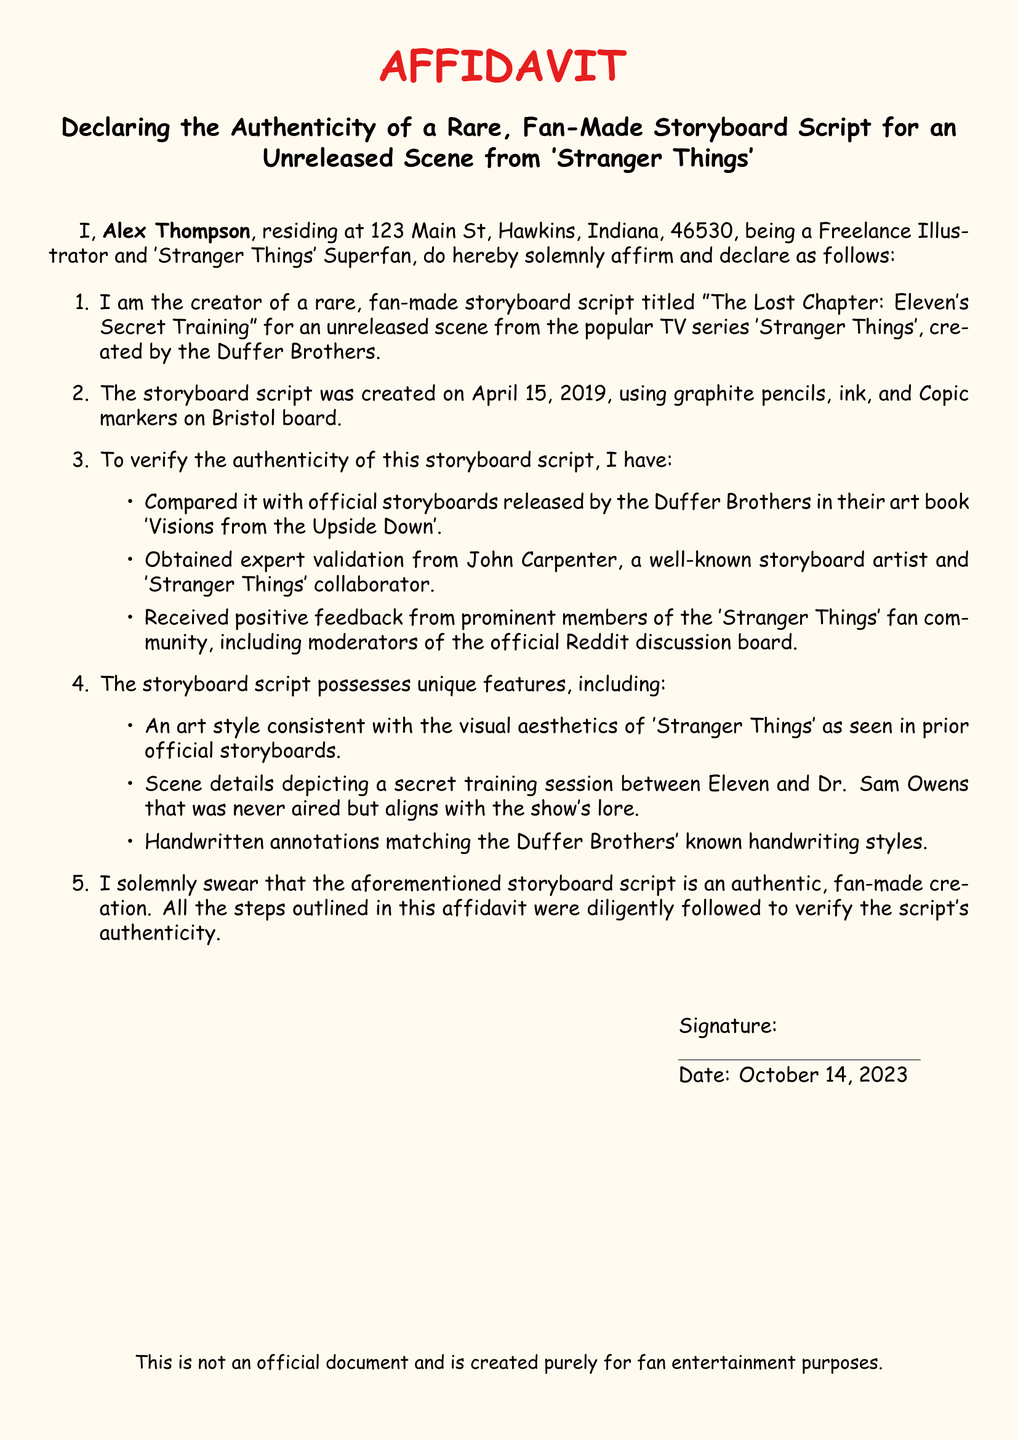What is the creator's name? The creator's name is stated in the affidavit as Alex Thompson.
Answer: Alex Thompson What is the title of the storyboard script? The title of the storyboard script is mentioned in the affidavit as "The Lost Chapter: Eleven's Secret Training".
Answer: The Lost Chapter: Eleven's Secret Training On what date was the storyboard script created? The date of creation is explicitly provided in the document as April 15, 2019.
Answer: April 15, 2019 Who validated the authenticity of the storyboard script? The affidavit lists John Carpenter as the individual who provided expert validation for the script's authenticity.
Answer: John Carpenter What is the significance of the scene in the storyboard? The document states that the scene depicts a secret training session between Eleven and Dr. Sam Owens.
Answer: Secret training session What materials were used to create the storyboard script? The affidavit specifies that graphite pencils, ink, and Copic markers on Bristol board were used.
Answer: Graphite pencils, ink, and Copic markers What feedback did the creator receive about the storyboard script? The creator received positive feedback from prominent members of the 'Stranger Things' fan community.
Answer: Positive feedback What color is the document's background? The affidavit describes the page color as a light shade, referred to as strangerbg.
Answer: strangerbg What does the creator affirm about the storyboard script? The creator solemnly affirms that the script is an authentic, fan-made creation.
Answer: Authentic, fan-made creation 